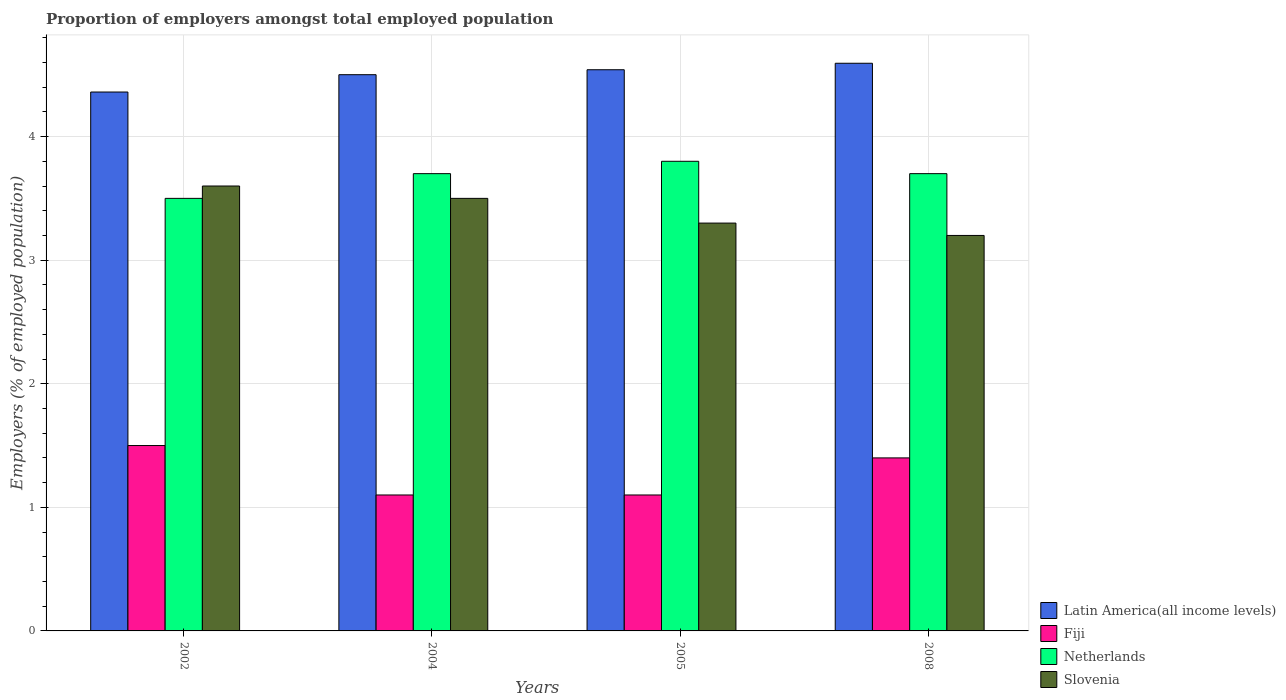Are the number of bars per tick equal to the number of legend labels?
Make the answer very short. Yes. Are the number of bars on each tick of the X-axis equal?
Provide a succinct answer. Yes. How many bars are there on the 1st tick from the right?
Provide a succinct answer. 4. What is the label of the 4th group of bars from the left?
Provide a succinct answer. 2008. What is the proportion of employers in Latin America(all income levels) in 2005?
Offer a very short reply. 4.54. Across all years, what is the minimum proportion of employers in Fiji?
Give a very brief answer. 1.1. What is the total proportion of employers in Slovenia in the graph?
Ensure brevity in your answer.  13.6. What is the difference between the proportion of employers in Slovenia in 2002 and that in 2005?
Provide a short and direct response. 0.3. What is the difference between the proportion of employers in Slovenia in 2008 and the proportion of employers in Latin America(all income levels) in 2005?
Make the answer very short. -1.34. What is the average proportion of employers in Netherlands per year?
Your response must be concise. 3.68. In the year 2004, what is the difference between the proportion of employers in Latin America(all income levels) and proportion of employers in Netherlands?
Provide a succinct answer. 0.8. In how many years, is the proportion of employers in Fiji greater than 3 %?
Ensure brevity in your answer.  0. Is the proportion of employers in Latin America(all income levels) in 2004 less than that in 2005?
Your answer should be very brief. Yes. What is the difference between the highest and the second highest proportion of employers in Latin America(all income levels)?
Make the answer very short. 0.05. What is the difference between the highest and the lowest proportion of employers in Latin America(all income levels)?
Give a very brief answer. 0.23. What does the 4th bar from the left in 2004 represents?
Offer a very short reply. Slovenia. What does the 4th bar from the right in 2002 represents?
Your response must be concise. Latin America(all income levels). Is it the case that in every year, the sum of the proportion of employers in Slovenia and proportion of employers in Fiji is greater than the proportion of employers in Latin America(all income levels)?
Your answer should be very brief. No. How many bars are there?
Keep it short and to the point. 16. How many years are there in the graph?
Ensure brevity in your answer.  4. What is the difference between two consecutive major ticks on the Y-axis?
Offer a very short reply. 1. Does the graph contain grids?
Keep it short and to the point. Yes. How are the legend labels stacked?
Your response must be concise. Vertical. What is the title of the graph?
Offer a very short reply. Proportion of employers amongst total employed population. Does "Sweden" appear as one of the legend labels in the graph?
Your answer should be very brief. No. What is the label or title of the Y-axis?
Offer a very short reply. Employers (% of employed population). What is the Employers (% of employed population) in Latin America(all income levels) in 2002?
Provide a short and direct response. 4.36. What is the Employers (% of employed population) in Slovenia in 2002?
Provide a succinct answer. 3.6. What is the Employers (% of employed population) of Latin America(all income levels) in 2004?
Offer a terse response. 4.5. What is the Employers (% of employed population) of Fiji in 2004?
Provide a short and direct response. 1.1. What is the Employers (% of employed population) in Netherlands in 2004?
Give a very brief answer. 3.7. What is the Employers (% of employed population) of Latin America(all income levels) in 2005?
Your answer should be compact. 4.54. What is the Employers (% of employed population) of Fiji in 2005?
Provide a short and direct response. 1.1. What is the Employers (% of employed population) of Netherlands in 2005?
Provide a succinct answer. 3.8. What is the Employers (% of employed population) of Slovenia in 2005?
Keep it short and to the point. 3.3. What is the Employers (% of employed population) of Latin America(all income levels) in 2008?
Provide a short and direct response. 4.59. What is the Employers (% of employed population) of Fiji in 2008?
Provide a short and direct response. 1.4. What is the Employers (% of employed population) in Netherlands in 2008?
Your answer should be very brief. 3.7. What is the Employers (% of employed population) of Slovenia in 2008?
Provide a succinct answer. 3.2. Across all years, what is the maximum Employers (% of employed population) in Latin America(all income levels)?
Give a very brief answer. 4.59. Across all years, what is the maximum Employers (% of employed population) of Fiji?
Your response must be concise. 1.5. Across all years, what is the maximum Employers (% of employed population) in Netherlands?
Give a very brief answer. 3.8. Across all years, what is the maximum Employers (% of employed population) in Slovenia?
Give a very brief answer. 3.6. Across all years, what is the minimum Employers (% of employed population) in Latin America(all income levels)?
Provide a short and direct response. 4.36. Across all years, what is the minimum Employers (% of employed population) of Fiji?
Ensure brevity in your answer.  1.1. Across all years, what is the minimum Employers (% of employed population) of Slovenia?
Give a very brief answer. 3.2. What is the total Employers (% of employed population) of Latin America(all income levels) in the graph?
Keep it short and to the point. 18. What is the total Employers (% of employed population) of Slovenia in the graph?
Your answer should be very brief. 13.6. What is the difference between the Employers (% of employed population) of Latin America(all income levels) in 2002 and that in 2004?
Your answer should be compact. -0.14. What is the difference between the Employers (% of employed population) of Fiji in 2002 and that in 2004?
Offer a very short reply. 0.4. What is the difference between the Employers (% of employed population) in Netherlands in 2002 and that in 2004?
Keep it short and to the point. -0.2. What is the difference between the Employers (% of employed population) of Latin America(all income levels) in 2002 and that in 2005?
Provide a short and direct response. -0.18. What is the difference between the Employers (% of employed population) of Fiji in 2002 and that in 2005?
Provide a succinct answer. 0.4. What is the difference between the Employers (% of employed population) in Slovenia in 2002 and that in 2005?
Your answer should be very brief. 0.3. What is the difference between the Employers (% of employed population) in Latin America(all income levels) in 2002 and that in 2008?
Provide a short and direct response. -0.23. What is the difference between the Employers (% of employed population) of Netherlands in 2002 and that in 2008?
Keep it short and to the point. -0.2. What is the difference between the Employers (% of employed population) in Slovenia in 2002 and that in 2008?
Provide a succinct answer. 0.4. What is the difference between the Employers (% of employed population) in Latin America(all income levels) in 2004 and that in 2005?
Make the answer very short. -0.04. What is the difference between the Employers (% of employed population) in Netherlands in 2004 and that in 2005?
Your answer should be very brief. -0.1. What is the difference between the Employers (% of employed population) of Slovenia in 2004 and that in 2005?
Your response must be concise. 0.2. What is the difference between the Employers (% of employed population) in Latin America(all income levels) in 2004 and that in 2008?
Provide a succinct answer. -0.09. What is the difference between the Employers (% of employed population) of Netherlands in 2004 and that in 2008?
Keep it short and to the point. 0. What is the difference between the Employers (% of employed population) in Slovenia in 2004 and that in 2008?
Offer a very short reply. 0.3. What is the difference between the Employers (% of employed population) of Latin America(all income levels) in 2005 and that in 2008?
Your answer should be compact. -0.05. What is the difference between the Employers (% of employed population) in Fiji in 2005 and that in 2008?
Your answer should be compact. -0.3. What is the difference between the Employers (% of employed population) in Latin America(all income levels) in 2002 and the Employers (% of employed population) in Fiji in 2004?
Your answer should be very brief. 3.26. What is the difference between the Employers (% of employed population) in Latin America(all income levels) in 2002 and the Employers (% of employed population) in Netherlands in 2004?
Your answer should be compact. 0.66. What is the difference between the Employers (% of employed population) in Latin America(all income levels) in 2002 and the Employers (% of employed population) in Slovenia in 2004?
Your answer should be compact. 0.86. What is the difference between the Employers (% of employed population) in Fiji in 2002 and the Employers (% of employed population) in Netherlands in 2004?
Your answer should be compact. -2.2. What is the difference between the Employers (% of employed population) of Netherlands in 2002 and the Employers (% of employed population) of Slovenia in 2004?
Provide a short and direct response. 0. What is the difference between the Employers (% of employed population) in Latin America(all income levels) in 2002 and the Employers (% of employed population) in Fiji in 2005?
Offer a very short reply. 3.26. What is the difference between the Employers (% of employed population) in Latin America(all income levels) in 2002 and the Employers (% of employed population) in Netherlands in 2005?
Your answer should be very brief. 0.56. What is the difference between the Employers (% of employed population) in Latin America(all income levels) in 2002 and the Employers (% of employed population) in Slovenia in 2005?
Your response must be concise. 1.06. What is the difference between the Employers (% of employed population) in Fiji in 2002 and the Employers (% of employed population) in Slovenia in 2005?
Keep it short and to the point. -1.8. What is the difference between the Employers (% of employed population) of Netherlands in 2002 and the Employers (% of employed population) of Slovenia in 2005?
Ensure brevity in your answer.  0.2. What is the difference between the Employers (% of employed population) of Latin America(all income levels) in 2002 and the Employers (% of employed population) of Fiji in 2008?
Your answer should be very brief. 2.96. What is the difference between the Employers (% of employed population) of Latin America(all income levels) in 2002 and the Employers (% of employed population) of Netherlands in 2008?
Make the answer very short. 0.66. What is the difference between the Employers (% of employed population) in Latin America(all income levels) in 2002 and the Employers (% of employed population) in Slovenia in 2008?
Your response must be concise. 1.16. What is the difference between the Employers (% of employed population) in Fiji in 2002 and the Employers (% of employed population) in Slovenia in 2008?
Offer a very short reply. -1.7. What is the difference between the Employers (% of employed population) in Latin America(all income levels) in 2004 and the Employers (% of employed population) in Fiji in 2005?
Make the answer very short. 3.4. What is the difference between the Employers (% of employed population) of Latin America(all income levels) in 2004 and the Employers (% of employed population) of Netherlands in 2005?
Provide a short and direct response. 0.7. What is the difference between the Employers (% of employed population) of Latin America(all income levels) in 2004 and the Employers (% of employed population) of Slovenia in 2005?
Ensure brevity in your answer.  1.2. What is the difference between the Employers (% of employed population) in Fiji in 2004 and the Employers (% of employed population) in Slovenia in 2005?
Keep it short and to the point. -2.2. What is the difference between the Employers (% of employed population) of Netherlands in 2004 and the Employers (% of employed population) of Slovenia in 2005?
Give a very brief answer. 0.4. What is the difference between the Employers (% of employed population) in Latin America(all income levels) in 2004 and the Employers (% of employed population) in Fiji in 2008?
Your answer should be compact. 3.1. What is the difference between the Employers (% of employed population) of Latin America(all income levels) in 2004 and the Employers (% of employed population) of Netherlands in 2008?
Ensure brevity in your answer.  0.8. What is the difference between the Employers (% of employed population) of Latin America(all income levels) in 2004 and the Employers (% of employed population) of Slovenia in 2008?
Keep it short and to the point. 1.3. What is the difference between the Employers (% of employed population) in Fiji in 2004 and the Employers (% of employed population) in Slovenia in 2008?
Provide a short and direct response. -2.1. What is the difference between the Employers (% of employed population) in Netherlands in 2004 and the Employers (% of employed population) in Slovenia in 2008?
Make the answer very short. 0.5. What is the difference between the Employers (% of employed population) in Latin America(all income levels) in 2005 and the Employers (% of employed population) in Fiji in 2008?
Offer a terse response. 3.14. What is the difference between the Employers (% of employed population) of Latin America(all income levels) in 2005 and the Employers (% of employed population) of Netherlands in 2008?
Your answer should be compact. 0.84. What is the difference between the Employers (% of employed population) in Latin America(all income levels) in 2005 and the Employers (% of employed population) in Slovenia in 2008?
Give a very brief answer. 1.34. What is the difference between the Employers (% of employed population) in Fiji in 2005 and the Employers (% of employed population) in Netherlands in 2008?
Provide a short and direct response. -2.6. What is the difference between the Employers (% of employed population) in Netherlands in 2005 and the Employers (% of employed population) in Slovenia in 2008?
Ensure brevity in your answer.  0.6. What is the average Employers (% of employed population) of Latin America(all income levels) per year?
Give a very brief answer. 4.5. What is the average Employers (% of employed population) in Fiji per year?
Your response must be concise. 1.27. What is the average Employers (% of employed population) of Netherlands per year?
Provide a succinct answer. 3.67. In the year 2002, what is the difference between the Employers (% of employed population) in Latin America(all income levels) and Employers (% of employed population) in Fiji?
Keep it short and to the point. 2.86. In the year 2002, what is the difference between the Employers (% of employed population) of Latin America(all income levels) and Employers (% of employed population) of Netherlands?
Provide a short and direct response. 0.86. In the year 2002, what is the difference between the Employers (% of employed population) in Latin America(all income levels) and Employers (% of employed population) in Slovenia?
Keep it short and to the point. 0.76. In the year 2002, what is the difference between the Employers (% of employed population) of Fiji and Employers (% of employed population) of Slovenia?
Make the answer very short. -2.1. In the year 2002, what is the difference between the Employers (% of employed population) of Netherlands and Employers (% of employed population) of Slovenia?
Offer a terse response. -0.1. In the year 2004, what is the difference between the Employers (% of employed population) in Latin America(all income levels) and Employers (% of employed population) in Fiji?
Offer a terse response. 3.4. In the year 2004, what is the difference between the Employers (% of employed population) of Latin America(all income levels) and Employers (% of employed population) of Netherlands?
Give a very brief answer. 0.8. In the year 2004, what is the difference between the Employers (% of employed population) of Latin America(all income levels) and Employers (% of employed population) of Slovenia?
Your response must be concise. 1. In the year 2004, what is the difference between the Employers (% of employed population) of Fiji and Employers (% of employed population) of Netherlands?
Your response must be concise. -2.6. In the year 2004, what is the difference between the Employers (% of employed population) in Fiji and Employers (% of employed population) in Slovenia?
Your response must be concise. -2.4. In the year 2005, what is the difference between the Employers (% of employed population) in Latin America(all income levels) and Employers (% of employed population) in Fiji?
Provide a short and direct response. 3.44. In the year 2005, what is the difference between the Employers (% of employed population) of Latin America(all income levels) and Employers (% of employed population) of Netherlands?
Your answer should be very brief. 0.74. In the year 2005, what is the difference between the Employers (% of employed population) in Latin America(all income levels) and Employers (% of employed population) in Slovenia?
Provide a succinct answer. 1.24. In the year 2005, what is the difference between the Employers (% of employed population) of Fiji and Employers (% of employed population) of Netherlands?
Make the answer very short. -2.7. In the year 2005, what is the difference between the Employers (% of employed population) in Fiji and Employers (% of employed population) in Slovenia?
Provide a short and direct response. -2.2. In the year 2008, what is the difference between the Employers (% of employed population) in Latin America(all income levels) and Employers (% of employed population) in Fiji?
Offer a terse response. 3.19. In the year 2008, what is the difference between the Employers (% of employed population) in Latin America(all income levels) and Employers (% of employed population) in Netherlands?
Offer a very short reply. 0.89. In the year 2008, what is the difference between the Employers (% of employed population) in Latin America(all income levels) and Employers (% of employed population) in Slovenia?
Ensure brevity in your answer.  1.39. In the year 2008, what is the difference between the Employers (% of employed population) in Fiji and Employers (% of employed population) in Slovenia?
Ensure brevity in your answer.  -1.8. What is the ratio of the Employers (% of employed population) in Latin America(all income levels) in 2002 to that in 2004?
Provide a short and direct response. 0.97. What is the ratio of the Employers (% of employed population) of Fiji in 2002 to that in 2004?
Your response must be concise. 1.36. What is the ratio of the Employers (% of employed population) of Netherlands in 2002 to that in 2004?
Make the answer very short. 0.95. What is the ratio of the Employers (% of employed population) in Slovenia in 2002 to that in 2004?
Provide a short and direct response. 1.03. What is the ratio of the Employers (% of employed population) of Latin America(all income levels) in 2002 to that in 2005?
Give a very brief answer. 0.96. What is the ratio of the Employers (% of employed population) in Fiji in 2002 to that in 2005?
Make the answer very short. 1.36. What is the ratio of the Employers (% of employed population) in Netherlands in 2002 to that in 2005?
Make the answer very short. 0.92. What is the ratio of the Employers (% of employed population) of Latin America(all income levels) in 2002 to that in 2008?
Keep it short and to the point. 0.95. What is the ratio of the Employers (% of employed population) in Fiji in 2002 to that in 2008?
Give a very brief answer. 1.07. What is the ratio of the Employers (% of employed population) in Netherlands in 2002 to that in 2008?
Provide a short and direct response. 0.95. What is the ratio of the Employers (% of employed population) in Slovenia in 2002 to that in 2008?
Your answer should be compact. 1.12. What is the ratio of the Employers (% of employed population) in Latin America(all income levels) in 2004 to that in 2005?
Provide a succinct answer. 0.99. What is the ratio of the Employers (% of employed population) in Netherlands in 2004 to that in 2005?
Make the answer very short. 0.97. What is the ratio of the Employers (% of employed population) of Slovenia in 2004 to that in 2005?
Your response must be concise. 1.06. What is the ratio of the Employers (% of employed population) of Latin America(all income levels) in 2004 to that in 2008?
Make the answer very short. 0.98. What is the ratio of the Employers (% of employed population) of Fiji in 2004 to that in 2008?
Your answer should be compact. 0.79. What is the ratio of the Employers (% of employed population) in Netherlands in 2004 to that in 2008?
Your answer should be compact. 1. What is the ratio of the Employers (% of employed population) of Slovenia in 2004 to that in 2008?
Provide a succinct answer. 1.09. What is the ratio of the Employers (% of employed population) of Latin America(all income levels) in 2005 to that in 2008?
Your answer should be compact. 0.99. What is the ratio of the Employers (% of employed population) in Fiji in 2005 to that in 2008?
Offer a very short reply. 0.79. What is the ratio of the Employers (% of employed population) of Slovenia in 2005 to that in 2008?
Provide a short and direct response. 1.03. What is the difference between the highest and the second highest Employers (% of employed population) of Latin America(all income levels)?
Your response must be concise. 0.05. What is the difference between the highest and the second highest Employers (% of employed population) of Fiji?
Your response must be concise. 0.1. What is the difference between the highest and the second highest Employers (% of employed population) in Netherlands?
Offer a terse response. 0.1. What is the difference between the highest and the second highest Employers (% of employed population) in Slovenia?
Offer a terse response. 0.1. What is the difference between the highest and the lowest Employers (% of employed population) in Latin America(all income levels)?
Offer a very short reply. 0.23. What is the difference between the highest and the lowest Employers (% of employed population) in Slovenia?
Your answer should be compact. 0.4. 